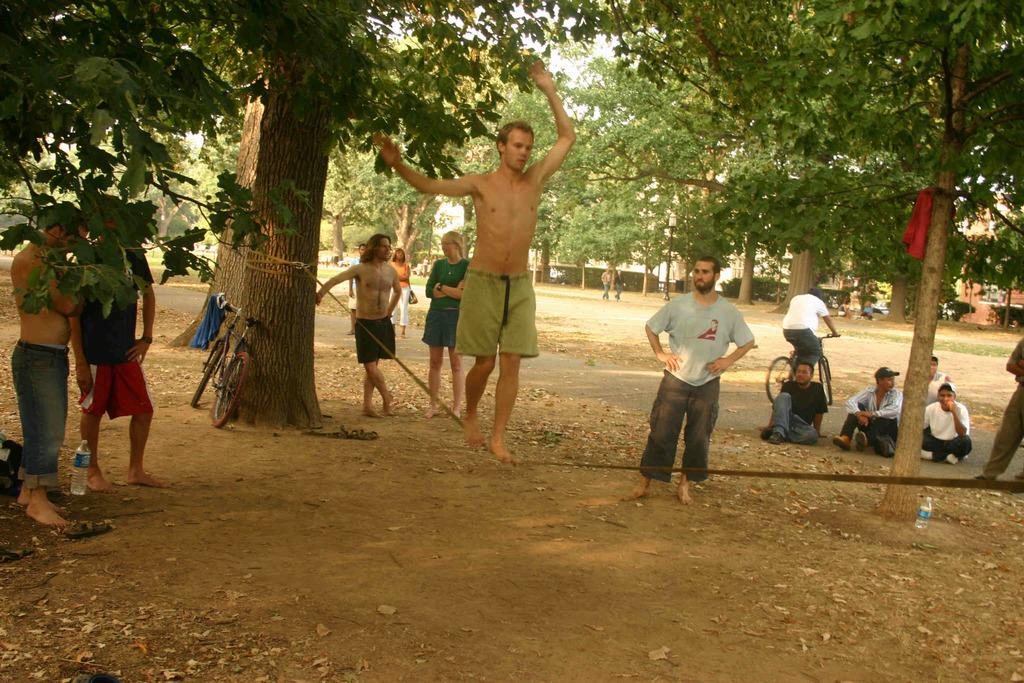How many people can be seen in the image? There are multiple people in the image. What are two different activities being performed by the people? One person is on a rope, and another person is cycling. What can be seen in the background of the image? There are lots of trees in the background. Is there any equipment related to the cycling activity visible in the image? Yes, there is a cycle in the background. Who is the manager of the cooking team in the image? There is no mention of a manager or cooking team in the image. What type of stretch can be seen in the image? There is no stretch visible in the image. 